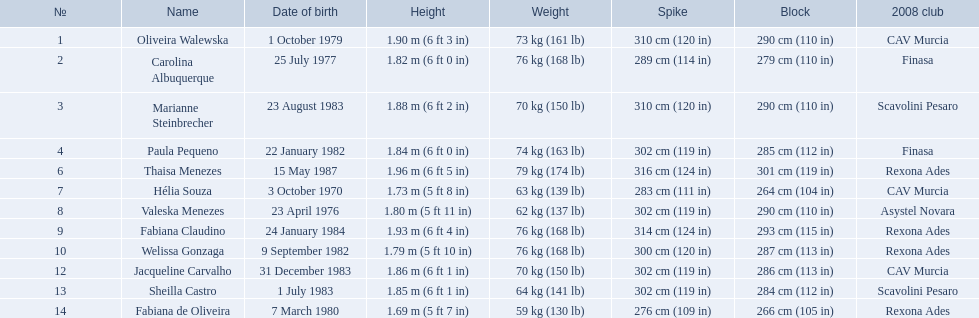What are the heights of the players? 1.90 m (6 ft 3 in), 1.82 m (6 ft 0 in), 1.88 m (6 ft 2 in), 1.84 m (6 ft 0 in), 1.96 m (6 ft 5 in), 1.73 m (5 ft 8 in), 1.80 m (5 ft 11 in), 1.93 m (6 ft 4 in), 1.79 m (5 ft 10 in), 1.86 m (6 ft 1 in), 1.85 m (6 ft 1 in), 1.69 m (5 ft 7 in). Which of these heights is the shortest? 1.69 m (5 ft 7 in). Which player is 5'7 tall? Fabiana de Oliveira. What are the full names of all the competitors? Oliveira Walewska, Carolina Albuquerque, Marianne Steinbrecher, Paula Pequeno, Thaisa Menezes, Hélia Souza, Valeska Menezes, Fabiana Claudino, Welissa Gonzaga, Jacqueline Carvalho, Sheilla Castro, Fabiana de Oliveira. What are the different weight classes for the contestants? 73 kg (161 lb), 76 kg (168 lb), 70 kg (150 lb), 74 kg (163 lb), 79 kg (174 lb), 63 kg (139 lb), 62 kg (137 lb), 76 kg (168 lb), 76 kg (168 lb), 70 kg (150 lb), 64 kg (141 lb), 59 kg (130 lb). Who has the greatest weight among sheilla castro, fabiana de oliveira, and helia souza? Sheilla Castro. 